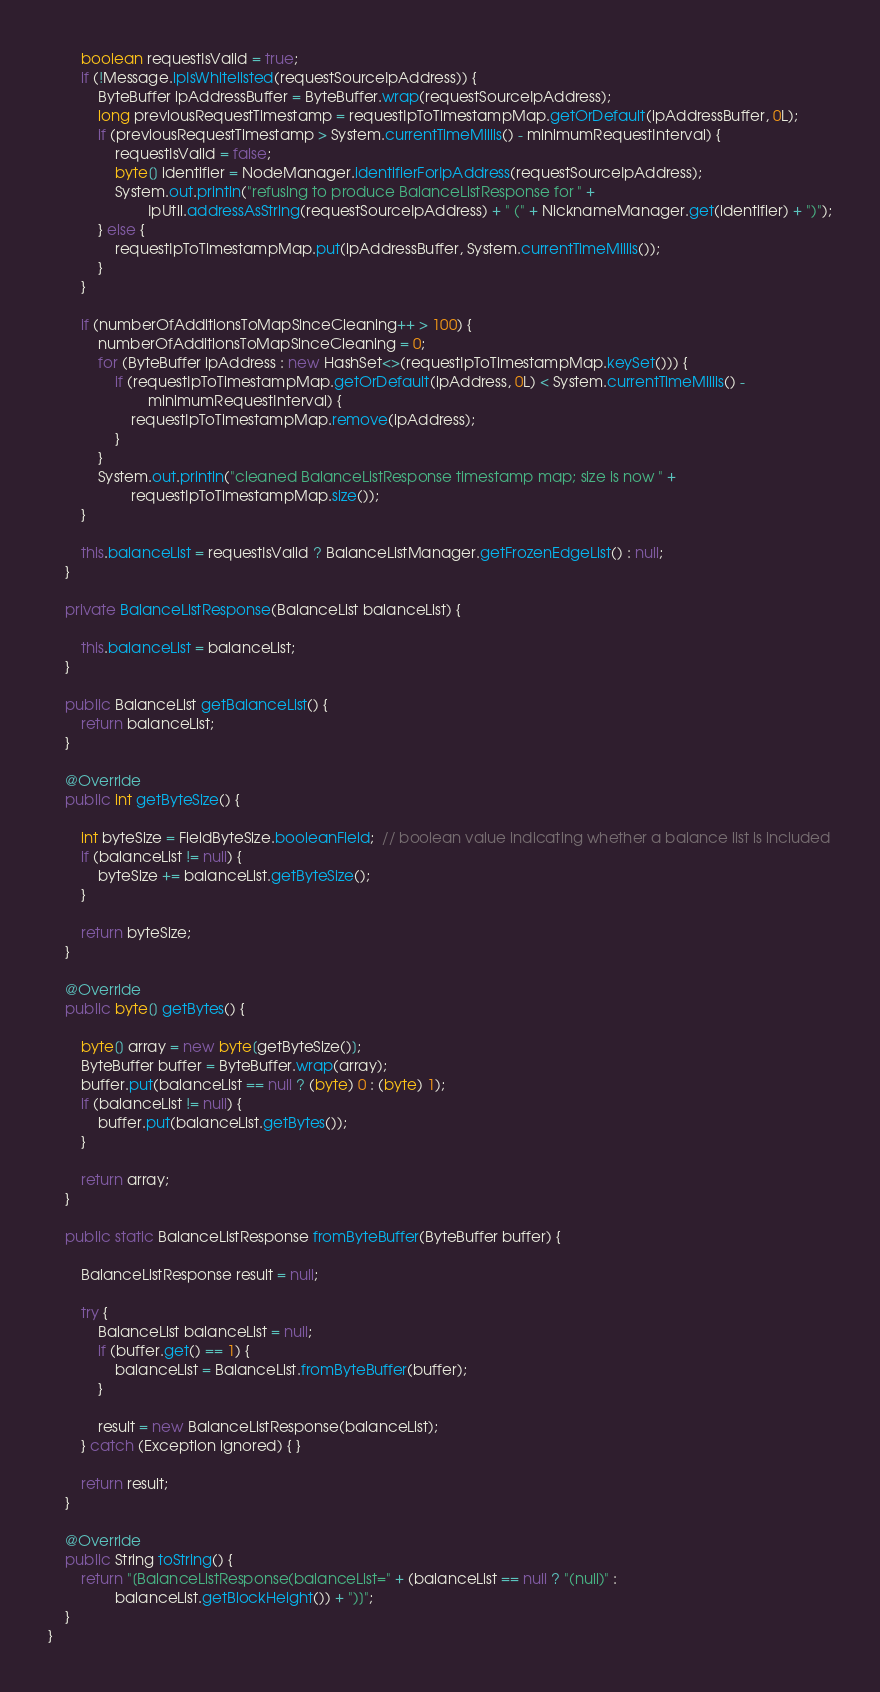Convert code to text. <code><loc_0><loc_0><loc_500><loc_500><_Java_>        boolean requestIsValid = true;
        if (!Message.ipIsWhitelisted(requestSourceIpAddress)) {
            ByteBuffer ipAddressBuffer = ByteBuffer.wrap(requestSourceIpAddress);
            long previousRequestTimestamp = requestIpToTimestampMap.getOrDefault(ipAddressBuffer, 0L);
            if (previousRequestTimestamp > System.currentTimeMillis() - minimumRequestInterval) {
                requestIsValid = false;
                byte[] identifier = NodeManager.identifierForIpAddress(requestSourceIpAddress);
                System.out.println("refusing to produce BalanceListResponse for " +
                        IpUtil.addressAsString(requestSourceIpAddress) + " (" + NicknameManager.get(identifier) + ")");
            } else {
                requestIpToTimestampMap.put(ipAddressBuffer, System.currentTimeMillis());
            }
        }

        if (numberOfAdditionsToMapSinceCleaning++ > 100) {
            numberOfAdditionsToMapSinceCleaning = 0;
            for (ByteBuffer ipAddress : new HashSet<>(requestIpToTimestampMap.keySet())) {
                if (requestIpToTimestampMap.getOrDefault(ipAddress, 0L) < System.currentTimeMillis() -
                        minimumRequestInterval) {
                    requestIpToTimestampMap.remove(ipAddress);
                }
            }
            System.out.println("cleaned BalanceListResponse timestamp map; size is now " +
                    requestIpToTimestampMap.size());
        }

        this.balanceList = requestIsValid ? BalanceListManager.getFrozenEdgeList() : null;
    }

    private BalanceListResponse(BalanceList balanceList) {

        this.balanceList = balanceList;
    }

    public BalanceList getBalanceList() {
        return balanceList;
    }

    @Override
    public int getByteSize() {

        int byteSize = FieldByteSize.booleanField;  // boolean value indicating whether a balance list is included
        if (balanceList != null) {
            byteSize += balanceList.getByteSize();
        }

        return byteSize;
    }

    @Override
    public byte[] getBytes() {

        byte[] array = new byte[getByteSize()];
        ByteBuffer buffer = ByteBuffer.wrap(array);
        buffer.put(balanceList == null ? (byte) 0 : (byte) 1);
        if (balanceList != null) {
            buffer.put(balanceList.getBytes());
        }

        return array;
    }

    public static BalanceListResponse fromByteBuffer(ByteBuffer buffer) {

        BalanceListResponse result = null;

        try {
            BalanceList balanceList = null;
            if (buffer.get() == 1) {
                balanceList = BalanceList.fromByteBuffer(buffer);
            }

            result = new BalanceListResponse(balanceList);
        } catch (Exception ignored) { }

        return result;
    }

    @Override
    public String toString() {
        return "[BalanceListResponse(balanceList=" + (balanceList == null ? "(null)" :
                balanceList.getBlockHeight()) + ")]";
    }
}
</code> 